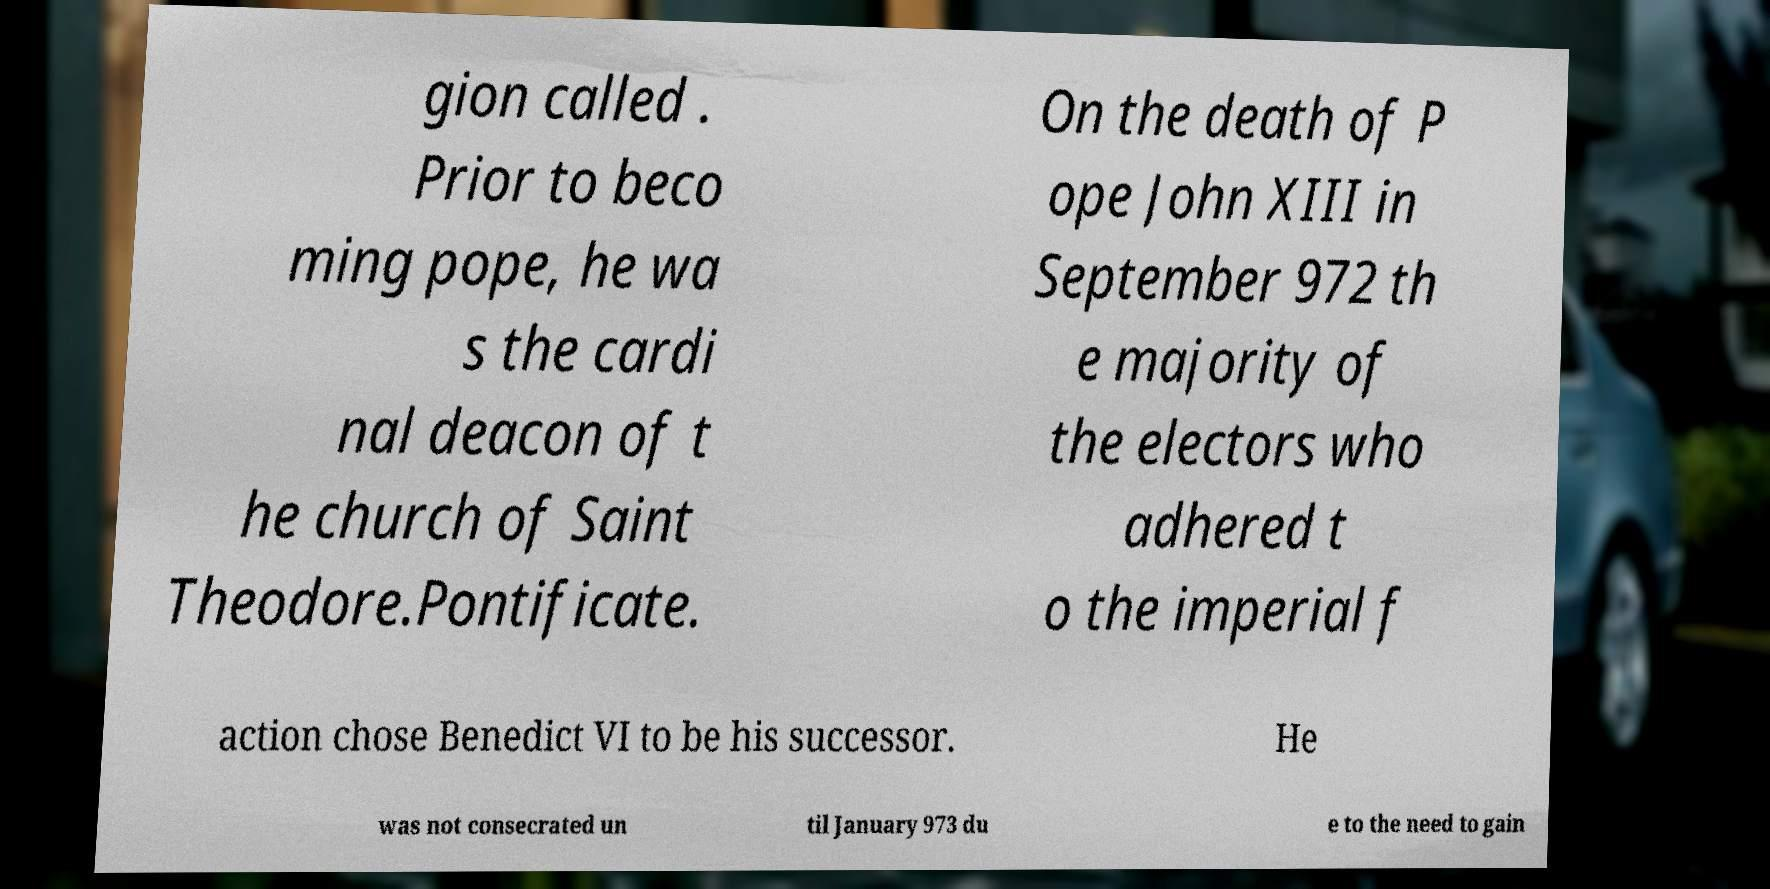For documentation purposes, I need the text within this image transcribed. Could you provide that? gion called . Prior to beco ming pope, he wa s the cardi nal deacon of t he church of Saint Theodore.Pontificate. On the death of P ope John XIII in September 972 th e majority of the electors who adhered t o the imperial f action chose Benedict VI to be his successor. He was not consecrated un til January 973 du e to the need to gain 